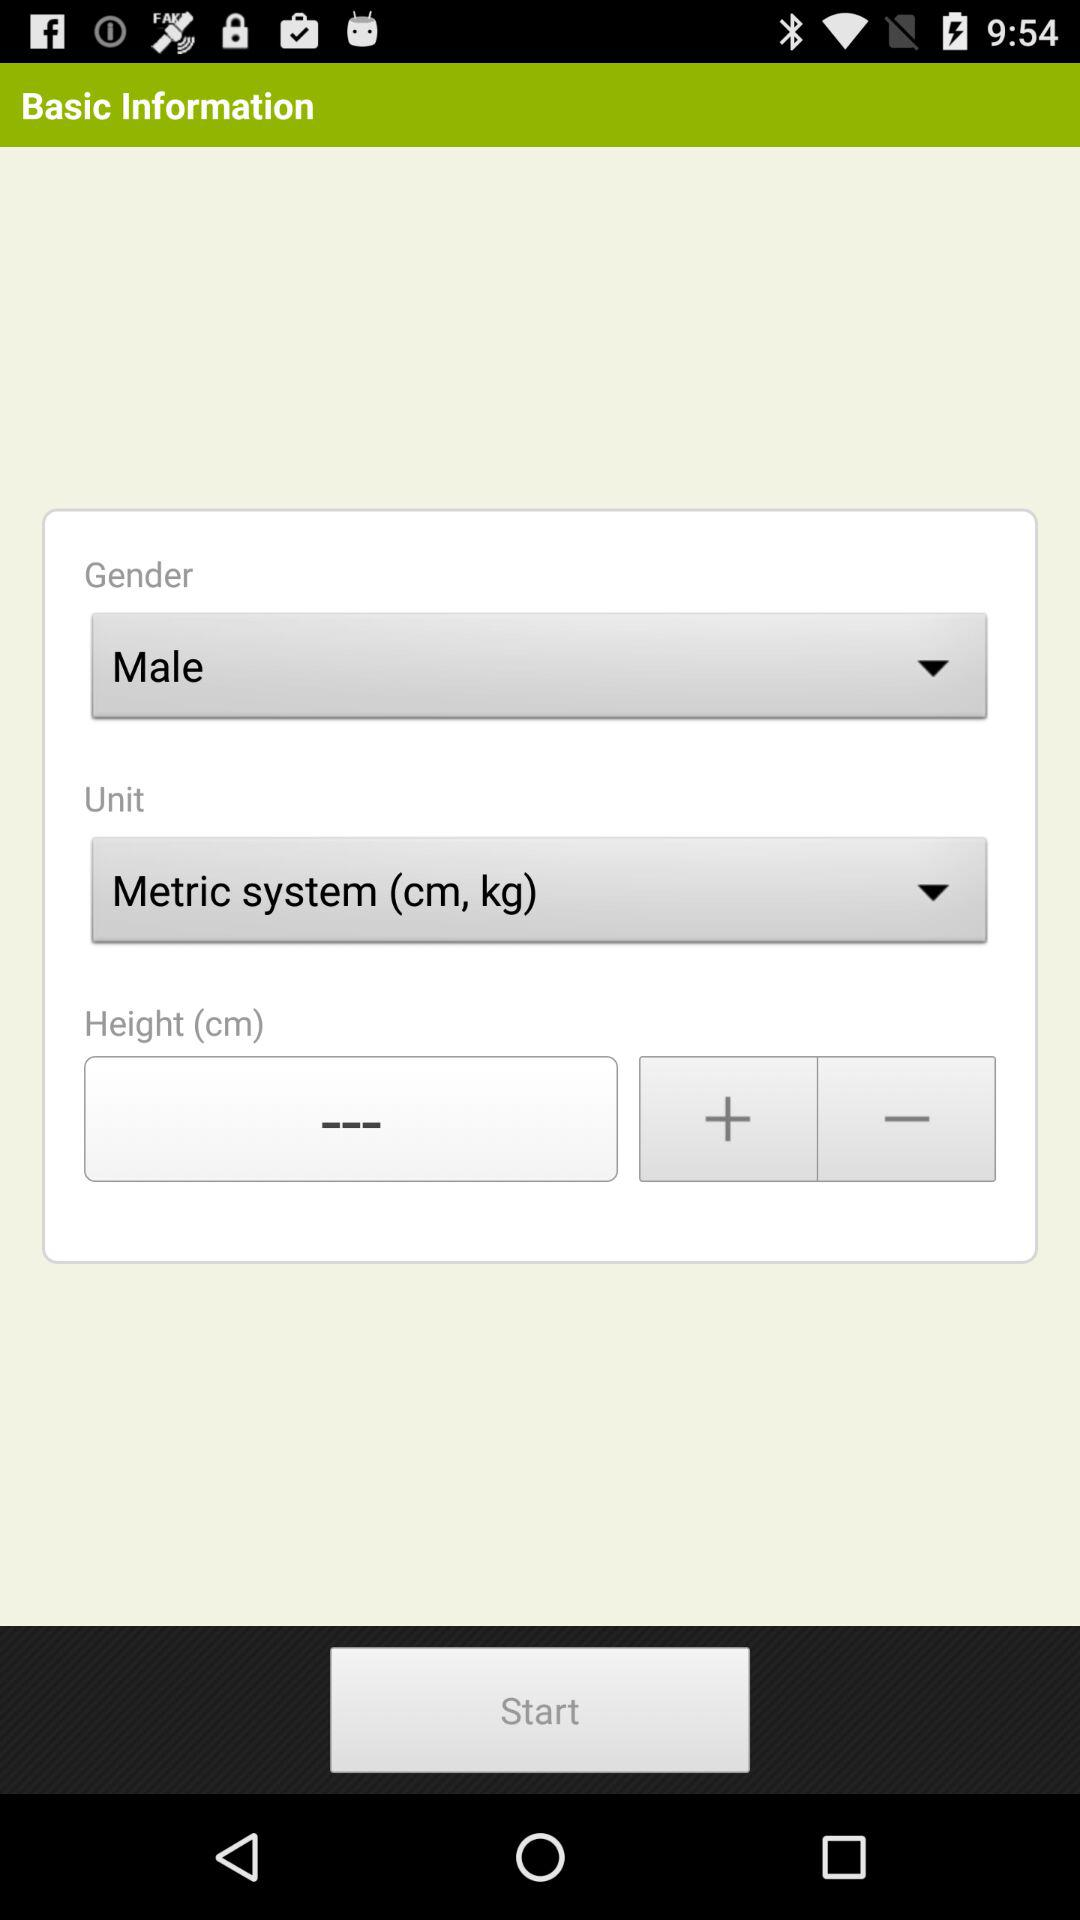What is the selected gender? The selected gender is male. 